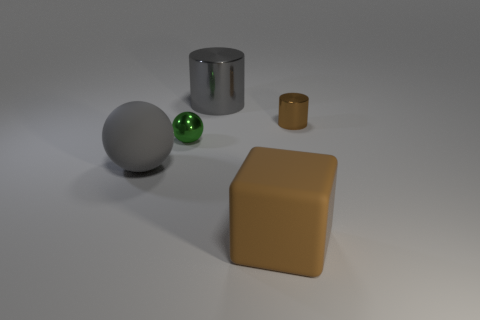Is the number of small purple rubber cylinders less than the number of tiny brown cylinders?
Your answer should be very brief. Yes. How many big shiny cylinders are the same color as the small metal sphere?
Ensure brevity in your answer.  0. There is a tiny cylinder that is the same color as the big matte block; what is it made of?
Your answer should be very brief. Metal. There is a tiny cylinder; does it have the same color as the matte object in front of the big gray matte object?
Provide a short and direct response. Yes. Are there more purple rubber cylinders than small green things?
Your answer should be compact. No. The rubber thing that is the same shape as the small green metallic thing is what size?
Offer a very short reply. Large. Do the brown cylinder and the large brown cube on the right side of the large gray cylinder have the same material?
Provide a short and direct response. No. How many objects are brown matte balls or tiny shiny objects?
Offer a very short reply. 2. Does the gray thing behind the tiny green metallic object have the same size as the metal thing in front of the small metallic cylinder?
Give a very brief answer. No. How many cubes are green metallic things or tiny brown objects?
Ensure brevity in your answer.  0. 